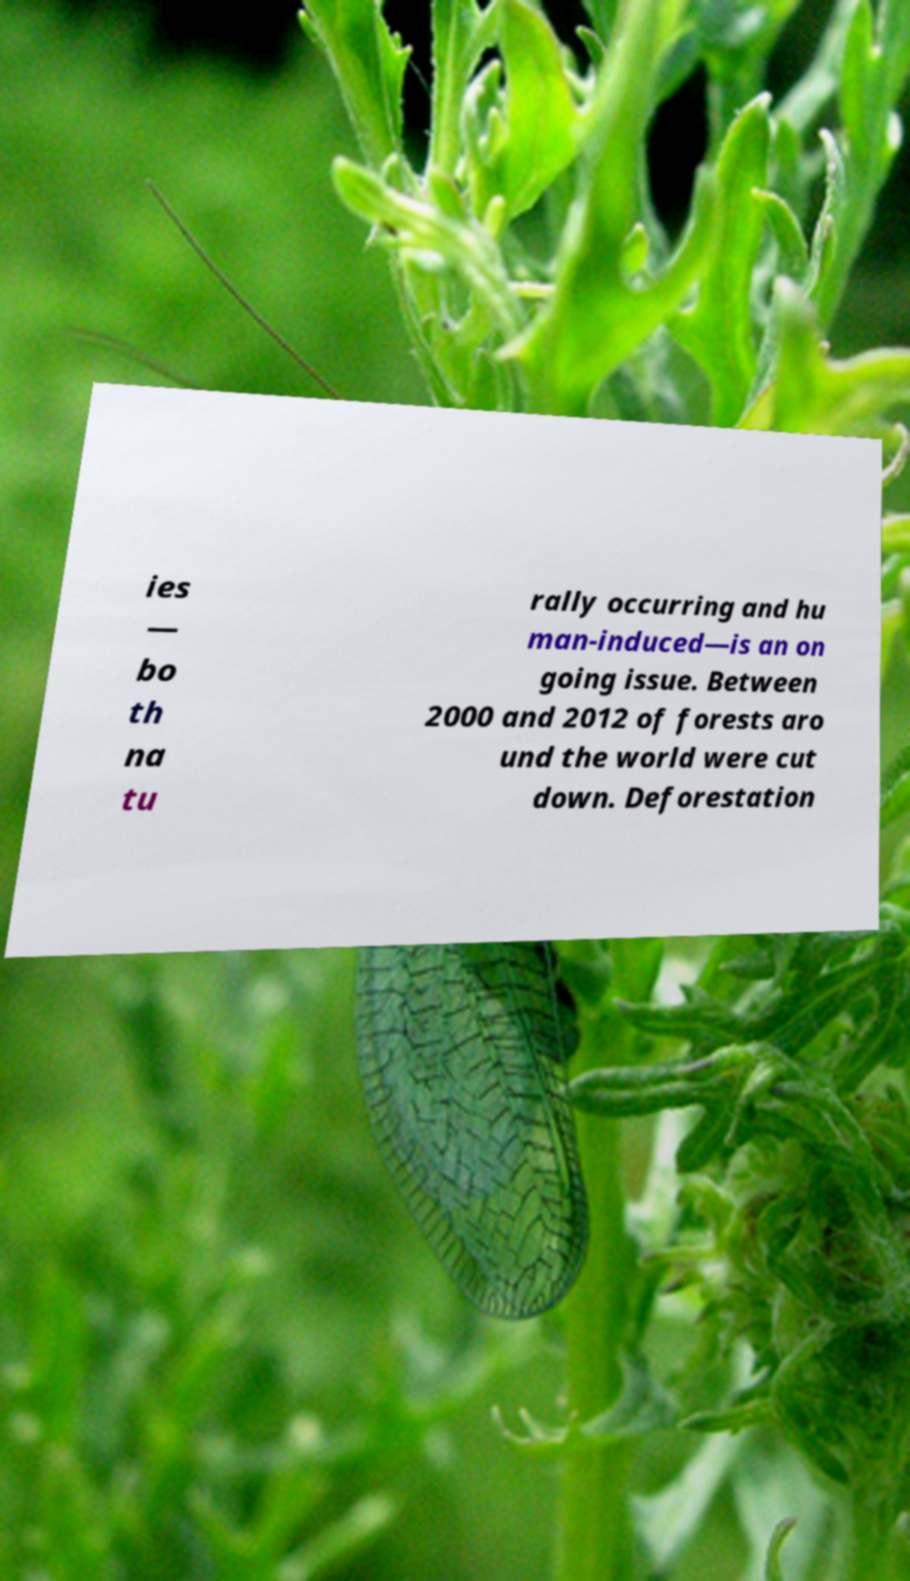Could you extract and type out the text from this image? ies — bo th na tu rally occurring and hu man-induced—is an on going issue. Between 2000 and 2012 of forests aro und the world were cut down. Deforestation 